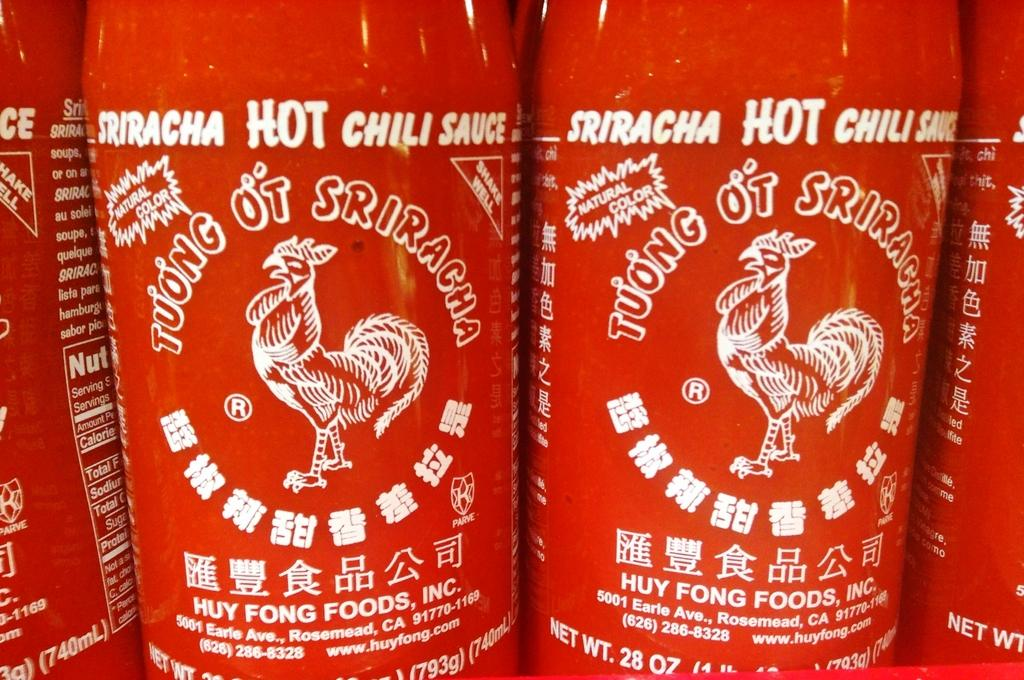<image>
Provide a brief description of the given image. Sriracha hot chili sauce lined up side by side 